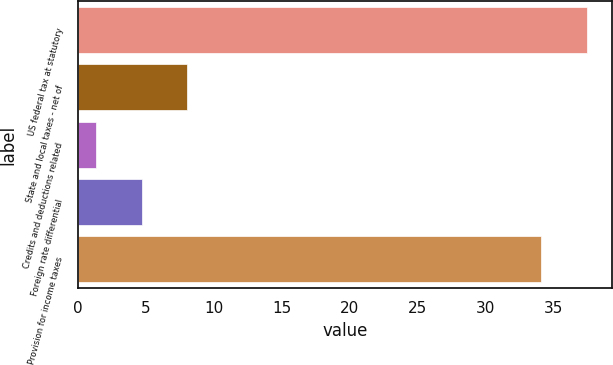Convert chart to OTSL. <chart><loc_0><loc_0><loc_500><loc_500><bar_chart><fcel>US federal tax at statutory<fcel>State and local taxes - net of<fcel>Credits and deductions related<fcel>Foreign rate differential<fcel>Provision for income taxes<nl><fcel>37.47<fcel>8.04<fcel>1.3<fcel>4.67<fcel>34.1<nl></chart> 